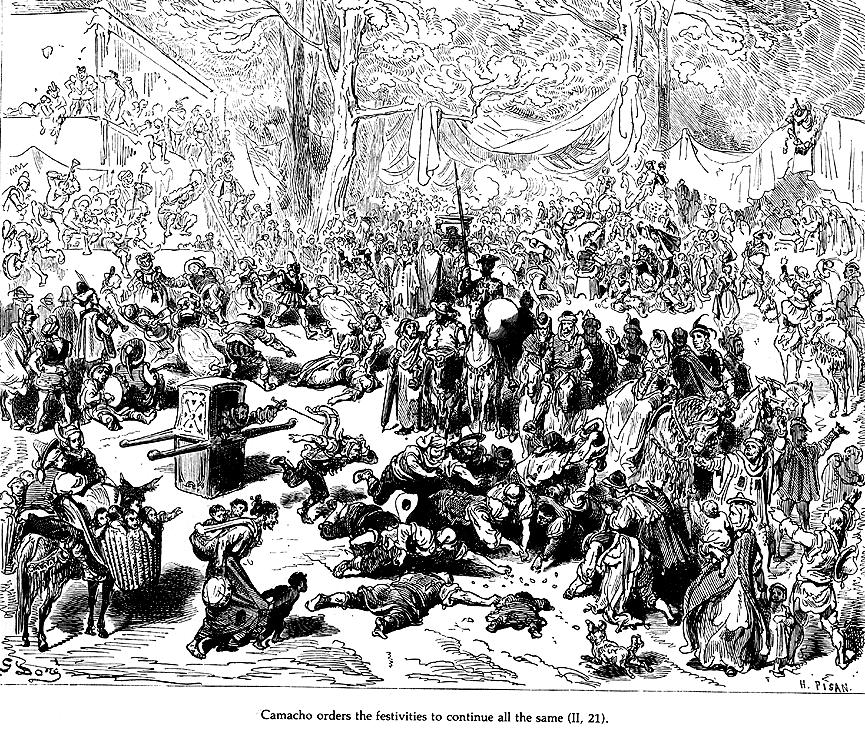What's happening in the scene? This black and white illustration is a rich depiction of a scene from 'Don Quixote' by Miguel de Cervantes. In the forest setting, a large assembly of people surrounds Camacho, who seems to be a figure of authority. They attentively listen as he ostensibly commands the festive activities to proceed unabated. The crowd, composed of various individuals including musicians and dancers, exudes a sense of lively enthusiasm. Detailed in a woodcut style, this illustration not only captures a moment of celebration and command but also subtly reveals the social interactions and costumes of the era, enhancing the viewer's understanding of the scene's historical context. The meticulous rendering of each character's attire and the dynamic arrangement of the figures add depth to this narrative scene. The inscription at the bottom, 'Camacho orders the festivities to continue all the same (p. 21),' crucially anchors the action in the story's plot, allowing viewers to connect the visual with the textual narrative of the novel. 